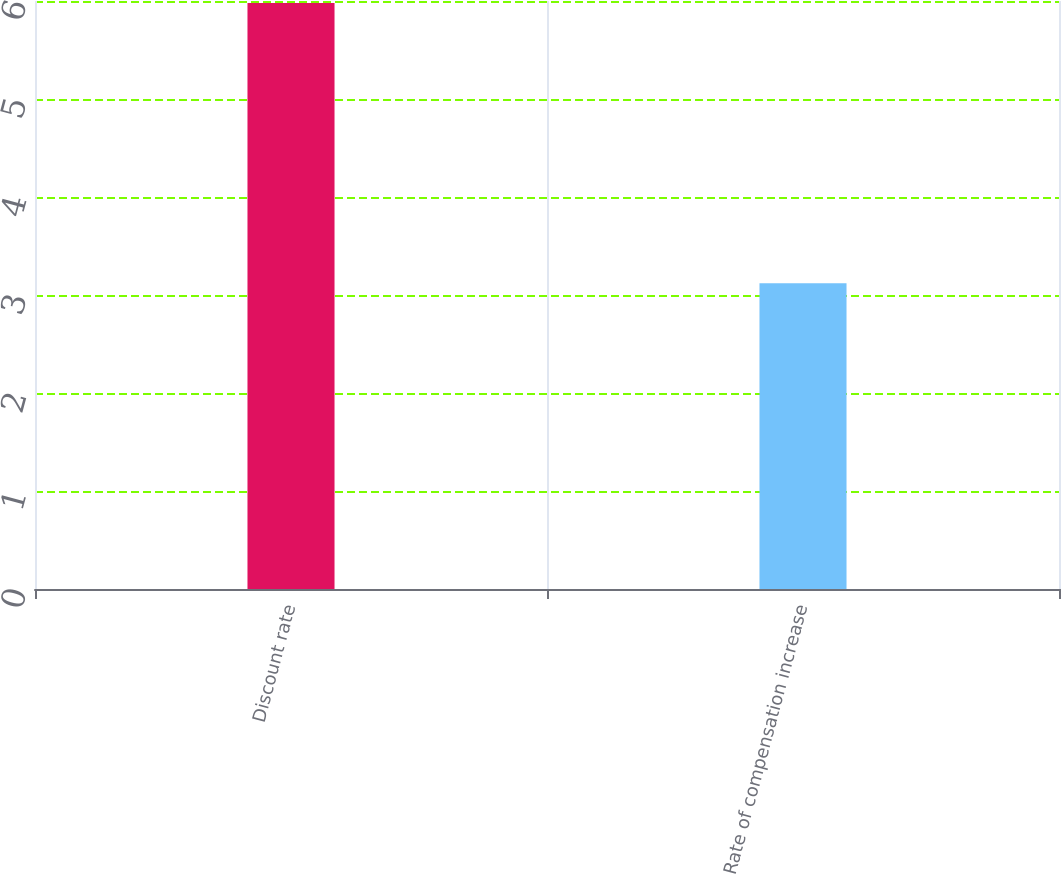Convert chart to OTSL. <chart><loc_0><loc_0><loc_500><loc_500><bar_chart><fcel>Discount rate<fcel>Rate of compensation increase<nl><fcel>5.98<fcel>3.12<nl></chart> 